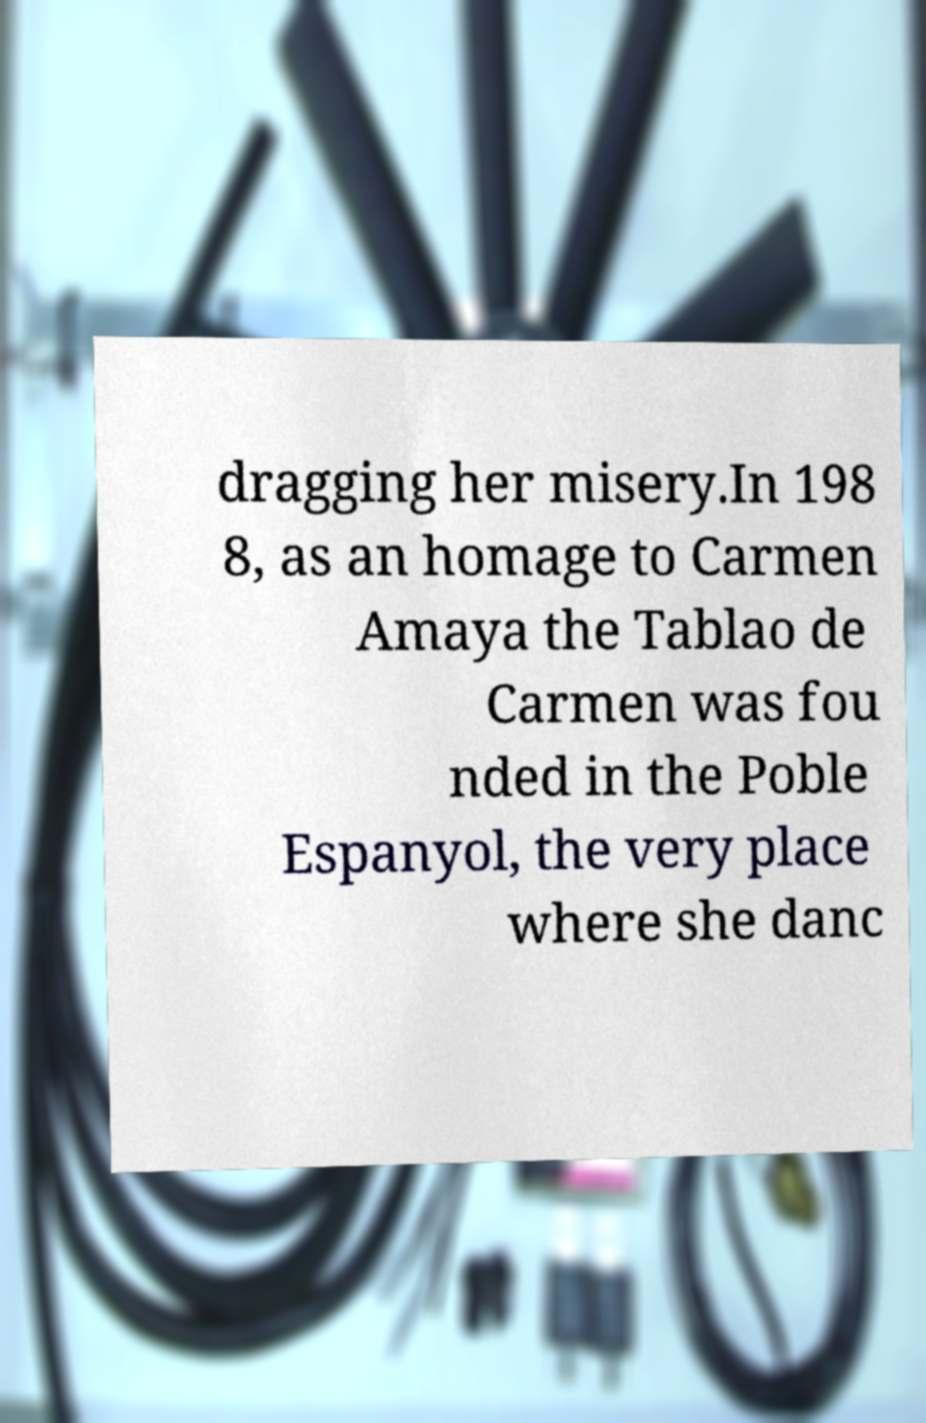Could you assist in decoding the text presented in this image and type it out clearly? dragging her misery.In 198 8, as an homage to Carmen Amaya the Tablao de Carmen was fou nded in the Poble Espanyol, the very place where she danc 